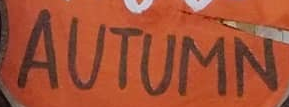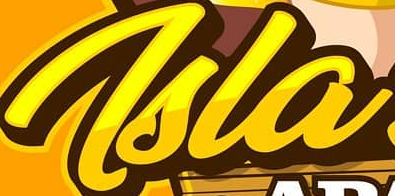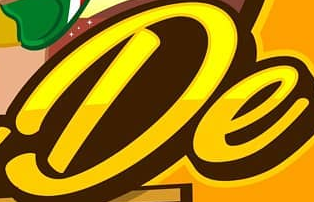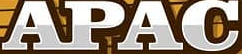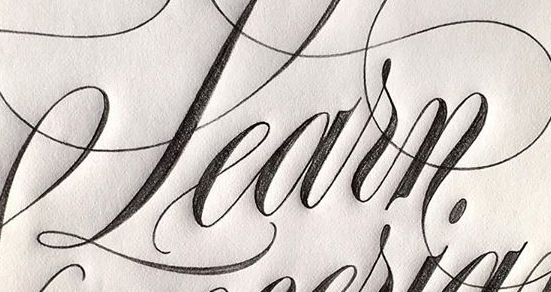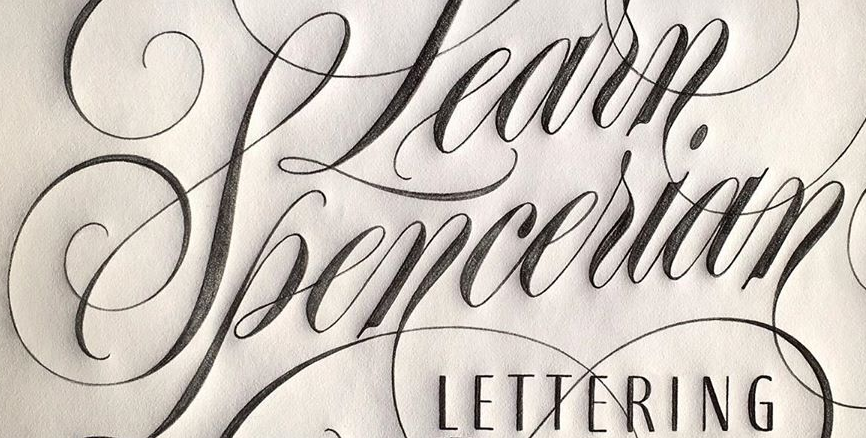What words can you see in these images in sequence, separated by a semicolon? AUTUMN; Tsla; De; APAC; Learn; Spencerian 